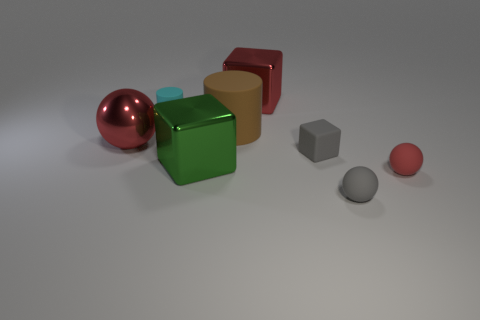What number of metal objects are tiny red spheres or large balls?
Make the answer very short. 1. There is a large thing that is both right of the large green thing and in front of the cyan rubber cylinder; what is its color?
Ensure brevity in your answer.  Brown. How many brown things are left of the big brown object?
Ensure brevity in your answer.  0. What is the material of the green object?
Offer a very short reply. Metal. The shiny block that is to the left of the big metallic cube that is behind the cylinder behind the big brown object is what color?
Ensure brevity in your answer.  Green. How many red shiny things have the same size as the brown matte cylinder?
Keep it short and to the point. 2. There is a big shiny block that is in front of the small cyan matte object; what color is it?
Offer a terse response. Green. How many other things are the same size as the brown rubber cylinder?
Your answer should be compact. 3. There is a thing that is both left of the red matte ball and right of the matte block; what size is it?
Your response must be concise. Small. There is a small matte block; does it have the same color as the ball that is in front of the small red matte object?
Your response must be concise. Yes. 